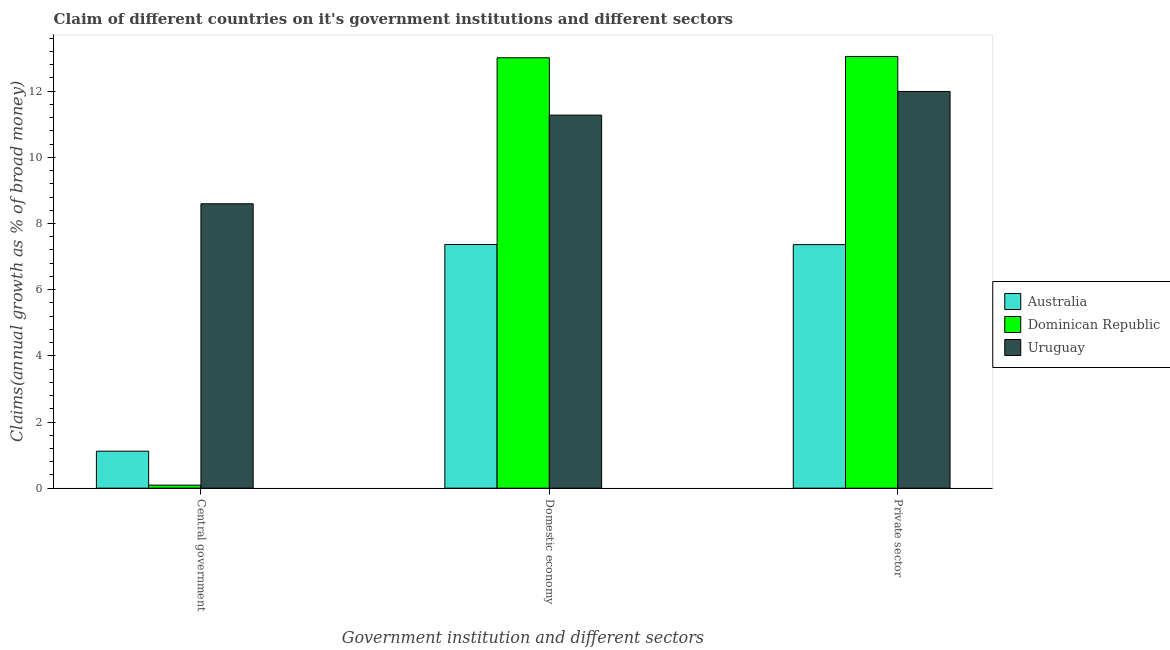How many different coloured bars are there?
Provide a short and direct response. 3. Are the number of bars on each tick of the X-axis equal?
Keep it short and to the point. Yes. How many bars are there on the 3rd tick from the left?
Offer a terse response. 3. What is the label of the 2nd group of bars from the left?
Your response must be concise. Domestic economy. What is the percentage of claim on the private sector in Australia?
Offer a terse response. 7.36. Across all countries, what is the maximum percentage of claim on the central government?
Your answer should be compact. 8.6. Across all countries, what is the minimum percentage of claim on the central government?
Provide a succinct answer. 0.09. In which country was the percentage of claim on the private sector maximum?
Your answer should be very brief. Dominican Republic. In which country was the percentage of claim on the central government minimum?
Give a very brief answer. Dominican Republic. What is the total percentage of claim on the domestic economy in the graph?
Keep it short and to the point. 31.66. What is the difference between the percentage of claim on the domestic economy in Australia and that in Uruguay?
Your response must be concise. -3.91. What is the difference between the percentage of claim on the central government in Uruguay and the percentage of claim on the domestic economy in Australia?
Your answer should be very brief. 1.23. What is the average percentage of claim on the domestic economy per country?
Your response must be concise. 10.55. What is the difference between the percentage of claim on the private sector and percentage of claim on the central government in Uruguay?
Your response must be concise. 3.4. What is the ratio of the percentage of claim on the private sector in Australia to that in Dominican Republic?
Make the answer very short. 0.56. What is the difference between the highest and the second highest percentage of claim on the private sector?
Make the answer very short. 1.06. What is the difference between the highest and the lowest percentage of claim on the domestic economy?
Your response must be concise. 5.64. In how many countries, is the percentage of claim on the domestic economy greater than the average percentage of claim on the domestic economy taken over all countries?
Offer a very short reply. 2. Is the sum of the percentage of claim on the domestic economy in Dominican Republic and Australia greater than the maximum percentage of claim on the central government across all countries?
Keep it short and to the point. Yes. What does the 1st bar from the right in Domestic economy represents?
Your response must be concise. Uruguay. Is it the case that in every country, the sum of the percentage of claim on the central government and percentage of claim on the domestic economy is greater than the percentage of claim on the private sector?
Your answer should be compact. Yes. Are all the bars in the graph horizontal?
Provide a succinct answer. No. How many countries are there in the graph?
Your answer should be compact. 3. Does the graph contain any zero values?
Give a very brief answer. No. How many legend labels are there?
Your answer should be very brief. 3. How are the legend labels stacked?
Your response must be concise. Vertical. What is the title of the graph?
Your answer should be compact. Claim of different countries on it's government institutions and different sectors. What is the label or title of the X-axis?
Keep it short and to the point. Government institution and different sectors. What is the label or title of the Y-axis?
Ensure brevity in your answer.  Claims(annual growth as % of broad money). What is the Claims(annual growth as % of broad money) in Australia in Central government?
Make the answer very short. 1.12. What is the Claims(annual growth as % of broad money) in Dominican Republic in Central government?
Offer a very short reply. 0.09. What is the Claims(annual growth as % of broad money) of Uruguay in Central government?
Give a very brief answer. 8.6. What is the Claims(annual growth as % of broad money) of Australia in Domestic economy?
Make the answer very short. 7.37. What is the Claims(annual growth as % of broad money) in Dominican Republic in Domestic economy?
Your answer should be very brief. 13.01. What is the Claims(annual growth as % of broad money) of Uruguay in Domestic economy?
Make the answer very short. 11.28. What is the Claims(annual growth as % of broad money) of Australia in Private sector?
Give a very brief answer. 7.36. What is the Claims(annual growth as % of broad money) in Dominican Republic in Private sector?
Offer a very short reply. 13.05. What is the Claims(annual growth as % of broad money) of Uruguay in Private sector?
Make the answer very short. 11.99. Across all Government institution and different sectors, what is the maximum Claims(annual growth as % of broad money) in Australia?
Ensure brevity in your answer.  7.37. Across all Government institution and different sectors, what is the maximum Claims(annual growth as % of broad money) of Dominican Republic?
Provide a short and direct response. 13.05. Across all Government institution and different sectors, what is the maximum Claims(annual growth as % of broad money) of Uruguay?
Provide a short and direct response. 11.99. Across all Government institution and different sectors, what is the minimum Claims(annual growth as % of broad money) of Australia?
Make the answer very short. 1.12. Across all Government institution and different sectors, what is the minimum Claims(annual growth as % of broad money) of Dominican Republic?
Your response must be concise. 0.09. Across all Government institution and different sectors, what is the minimum Claims(annual growth as % of broad money) of Uruguay?
Offer a very short reply. 8.6. What is the total Claims(annual growth as % of broad money) of Australia in the graph?
Your answer should be compact. 15.85. What is the total Claims(annual growth as % of broad money) in Dominican Republic in the graph?
Make the answer very short. 26.15. What is the total Claims(annual growth as % of broad money) of Uruguay in the graph?
Your answer should be very brief. 31.87. What is the difference between the Claims(annual growth as % of broad money) of Australia in Central government and that in Domestic economy?
Ensure brevity in your answer.  -6.25. What is the difference between the Claims(annual growth as % of broad money) in Dominican Republic in Central government and that in Domestic economy?
Your answer should be compact. -12.92. What is the difference between the Claims(annual growth as % of broad money) of Uruguay in Central government and that in Domestic economy?
Keep it short and to the point. -2.68. What is the difference between the Claims(annual growth as % of broad money) in Australia in Central government and that in Private sector?
Offer a very short reply. -6.25. What is the difference between the Claims(annual growth as % of broad money) in Dominican Republic in Central government and that in Private sector?
Offer a very short reply. -12.96. What is the difference between the Claims(annual growth as % of broad money) of Uruguay in Central government and that in Private sector?
Your answer should be very brief. -3.4. What is the difference between the Claims(annual growth as % of broad money) in Australia in Domestic economy and that in Private sector?
Offer a terse response. 0. What is the difference between the Claims(annual growth as % of broad money) in Dominican Republic in Domestic economy and that in Private sector?
Give a very brief answer. -0.04. What is the difference between the Claims(annual growth as % of broad money) of Uruguay in Domestic economy and that in Private sector?
Give a very brief answer. -0.72. What is the difference between the Claims(annual growth as % of broad money) of Australia in Central government and the Claims(annual growth as % of broad money) of Dominican Republic in Domestic economy?
Provide a succinct answer. -11.89. What is the difference between the Claims(annual growth as % of broad money) of Australia in Central government and the Claims(annual growth as % of broad money) of Uruguay in Domestic economy?
Make the answer very short. -10.16. What is the difference between the Claims(annual growth as % of broad money) of Dominican Republic in Central government and the Claims(annual growth as % of broad money) of Uruguay in Domestic economy?
Make the answer very short. -11.19. What is the difference between the Claims(annual growth as % of broad money) of Australia in Central government and the Claims(annual growth as % of broad money) of Dominican Republic in Private sector?
Your answer should be compact. -11.93. What is the difference between the Claims(annual growth as % of broad money) in Australia in Central government and the Claims(annual growth as % of broad money) in Uruguay in Private sector?
Your response must be concise. -10.87. What is the difference between the Claims(annual growth as % of broad money) in Dominican Republic in Central government and the Claims(annual growth as % of broad money) in Uruguay in Private sector?
Your response must be concise. -11.9. What is the difference between the Claims(annual growth as % of broad money) of Australia in Domestic economy and the Claims(annual growth as % of broad money) of Dominican Republic in Private sector?
Offer a very short reply. -5.68. What is the difference between the Claims(annual growth as % of broad money) of Australia in Domestic economy and the Claims(annual growth as % of broad money) of Uruguay in Private sector?
Your answer should be very brief. -4.63. What is the difference between the Claims(annual growth as % of broad money) of Dominican Republic in Domestic economy and the Claims(annual growth as % of broad money) of Uruguay in Private sector?
Ensure brevity in your answer.  1.02. What is the average Claims(annual growth as % of broad money) in Australia per Government institution and different sectors?
Offer a very short reply. 5.28. What is the average Claims(annual growth as % of broad money) of Dominican Republic per Government institution and different sectors?
Give a very brief answer. 8.72. What is the average Claims(annual growth as % of broad money) in Uruguay per Government institution and different sectors?
Provide a succinct answer. 10.62. What is the difference between the Claims(annual growth as % of broad money) in Australia and Claims(annual growth as % of broad money) in Dominican Republic in Central government?
Make the answer very short. 1.03. What is the difference between the Claims(annual growth as % of broad money) of Australia and Claims(annual growth as % of broad money) of Uruguay in Central government?
Your answer should be compact. -7.48. What is the difference between the Claims(annual growth as % of broad money) of Dominican Republic and Claims(annual growth as % of broad money) of Uruguay in Central government?
Make the answer very short. -8.51. What is the difference between the Claims(annual growth as % of broad money) of Australia and Claims(annual growth as % of broad money) of Dominican Republic in Domestic economy?
Make the answer very short. -5.64. What is the difference between the Claims(annual growth as % of broad money) of Australia and Claims(annual growth as % of broad money) of Uruguay in Domestic economy?
Provide a succinct answer. -3.91. What is the difference between the Claims(annual growth as % of broad money) of Dominican Republic and Claims(annual growth as % of broad money) of Uruguay in Domestic economy?
Your response must be concise. 1.73. What is the difference between the Claims(annual growth as % of broad money) in Australia and Claims(annual growth as % of broad money) in Dominican Republic in Private sector?
Provide a short and direct response. -5.69. What is the difference between the Claims(annual growth as % of broad money) of Australia and Claims(annual growth as % of broad money) of Uruguay in Private sector?
Offer a terse response. -4.63. What is the difference between the Claims(annual growth as % of broad money) of Dominican Republic and Claims(annual growth as % of broad money) of Uruguay in Private sector?
Your answer should be compact. 1.06. What is the ratio of the Claims(annual growth as % of broad money) in Australia in Central government to that in Domestic economy?
Your response must be concise. 0.15. What is the ratio of the Claims(annual growth as % of broad money) of Dominican Republic in Central government to that in Domestic economy?
Make the answer very short. 0.01. What is the ratio of the Claims(annual growth as % of broad money) in Uruguay in Central government to that in Domestic economy?
Give a very brief answer. 0.76. What is the ratio of the Claims(annual growth as % of broad money) of Australia in Central government to that in Private sector?
Provide a short and direct response. 0.15. What is the ratio of the Claims(annual growth as % of broad money) of Dominican Republic in Central government to that in Private sector?
Your response must be concise. 0.01. What is the ratio of the Claims(annual growth as % of broad money) in Uruguay in Central government to that in Private sector?
Your answer should be very brief. 0.72. What is the ratio of the Claims(annual growth as % of broad money) of Australia in Domestic economy to that in Private sector?
Your response must be concise. 1. What is the ratio of the Claims(annual growth as % of broad money) in Uruguay in Domestic economy to that in Private sector?
Ensure brevity in your answer.  0.94. What is the difference between the highest and the second highest Claims(annual growth as % of broad money) in Australia?
Ensure brevity in your answer.  0. What is the difference between the highest and the second highest Claims(annual growth as % of broad money) of Dominican Republic?
Make the answer very short. 0.04. What is the difference between the highest and the second highest Claims(annual growth as % of broad money) of Uruguay?
Provide a short and direct response. 0.72. What is the difference between the highest and the lowest Claims(annual growth as % of broad money) of Australia?
Provide a succinct answer. 6.25. What is the difference between the highest and the lowest Claims(annual growth as % of broad money) in Dominican Republic?
Your response must be concise. 12.96. What is the difference between the highest and the lowest Claims(annual growth as % of broad money) in Uruguay?
Provide a succinct answer. 3.4. 